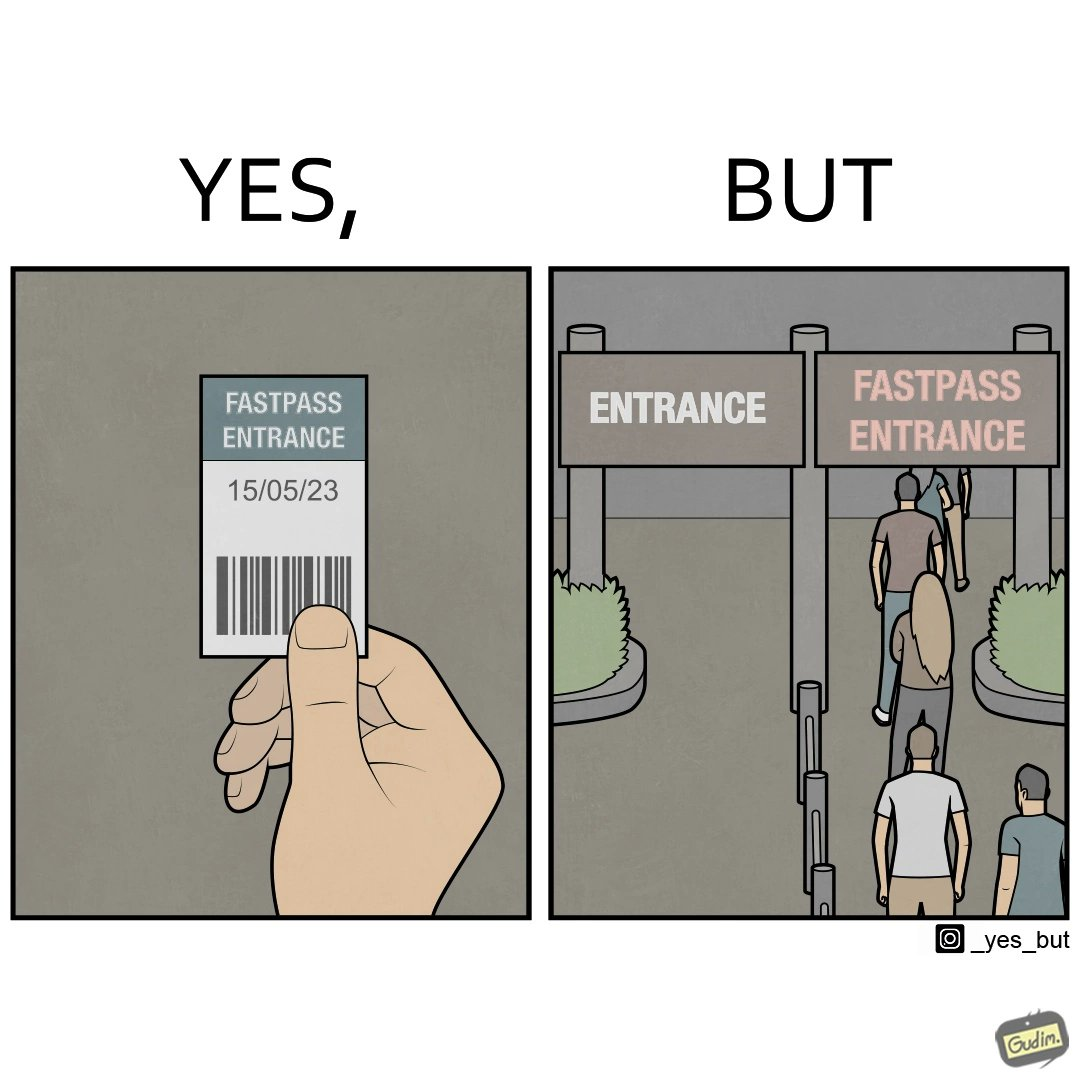Describe the satirical element in this image. The image is ironic, because fast pass entrance was meant for people to pass the gate fast but as more no. of people bought the pass due to which the queue has become longer and it becomes slow and time consuming 